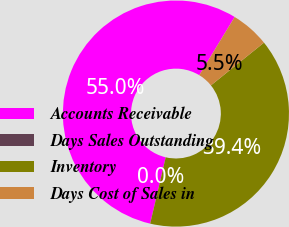<chart> <loc_0><loc_0><loc_500><loc_500><pie_chart><fcel>Accounts Receivable<fcel>Days Sales Outstanding<fcel>Inventory<fcel>Days Cost of Sales in<nl><fcel>55.04%<fcel>0.01%<fcel>39.45%<fcel>5.51%<nl></chart> 